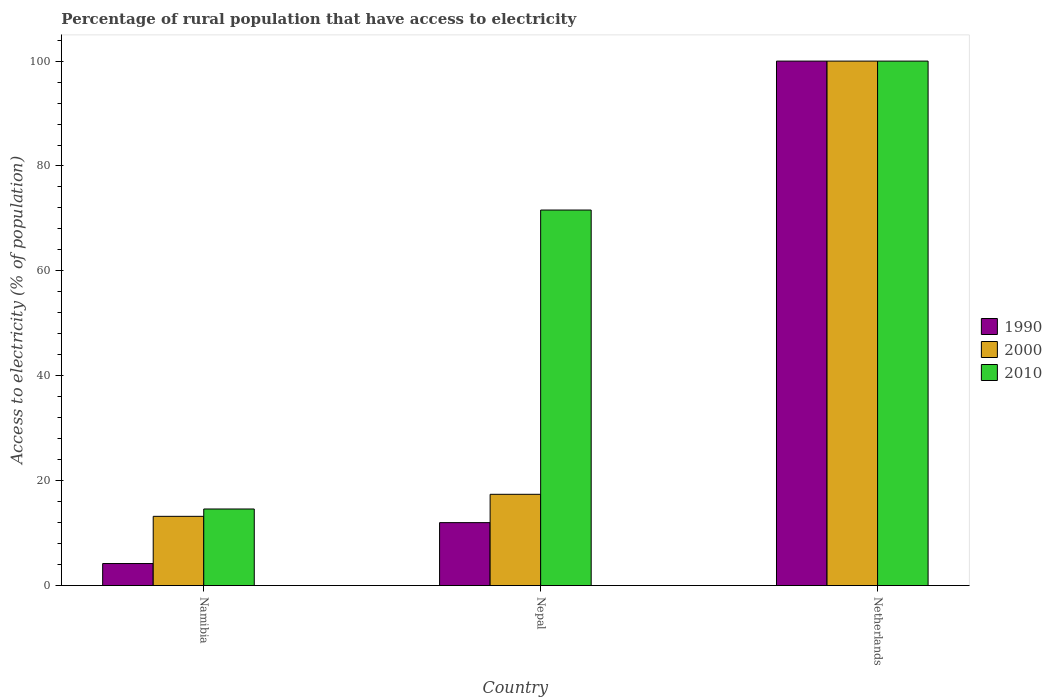Are the number of bars on each tick of the X-axis equal?
Offer a terse response. Yes. How many bars are there on the 2nd tick from the left?
Provide a succinct answer. 3. What is the label of the 2nd group of bars from the left?
Ensure brevity in your answer.  Nepal. Across all countries, what is the maximum percentage of rural population that have access to electricity in 2000?
Give a very brief answer. 100. In which country was the percentage of rural population that have access to electricity in 2010 minimum?
Your answer should be compact. Namibia. What is the total percentage of rural population that have access to electricity in 1990 in the graph?
Make the answer very short. 116.2. What is the difference between the percentage of rural population that have access to electricity in 1990 in Namibia and that in Netherlands?
Your answer should be very brief. -95.8. What is the difference between the percentage of rural population that have access to electricity in 2010 in Netherlands and the percentage of rural population that have access to electricity in 1990 in Namibia?
Give a very brief answer. 95.8. What is the average percentage of rural population that have access to electricity in 2010 per country?
Offer a very short reply. 62.07. What is the difference between the percentage of rural population that have access to electricity of/in 1990 and percentage of rural population that have access to electricity of/in 2000 in Namibia?
Ensure brevity in your answer.  -9. In how many countries, is the percentage of rural population that have access to electricity in 2010 greater than 68 %?
Offer a terse response. 2. What is the ratio of the percentage of rural population that have access to electricity in 1990 in Namibia to that in Nepal?
Offer a very short reply. 0.35. Is the percentage of rural population that have access to electricity in 2010 in Nepal less than that in Netherlands?
Offer a very short reply. Yes. What is the difference between the highest and the second highest percentage of rural population that have access to electricity in 2010?
Provide a short and direct response. 85.4. What is the difference between the highest and the lowest percentage of rural population that have access to electricity in 2010?
Keep it short and to the point. 85.4. In how many countries, is the percentage of rural population that have access to electricity in 2000 greater than the average percentage of rural population that have access to electricity in 2000 taken over all countries?
Provide a succinct answer. 1. Is the sum of the percentage of rural population that have access to electricity in 2010 in Nepal and Netherlands greater than the maximum percentage of rural population that have access to electricity in 2000 across all countries?
Give a very brief answer. Yes. What does the 3rd bar from the left in Nepal represents?
Your answer should be very brief. 2010. What does the 3rd bar from the right in Netherlands represents?
Offer a terse response. 1990. How many bars are there?
Your answer should be compact. 9. Are all the bars in the graph horizontal?
Give a very brief answer. No. What is the difference between two consecutive major ticks on the Y-axis?
Your answer should be compact. 20. Are the values on the major ticks of Y-axis written in scientific E-notation?
Make the answer very short. No. Where does the legend appear in the graph?
Make the answer very short. Center right. How many legend labels are there?
Offer a very short reply. 3. What is the title of the graph?
Your answer should be compact. Percentage of rural population that have access to electricity. Does "2008" appear as one of the legend labels in the graph?
Your answer should be compact. No. What is the label or title of the X-axis?
Your answer should be very brief. Country. What is the label or title of the Y-axis?
Make the answer very short. Access to electricity (% of population). What is the Access to electricity (% of population) of 1990 in Namibia?
Give a very brief answer. 4.2. What is the Access to electricity (% of population) in 2000 in Namibia?
Your response must be concise. 13.2. What is the Access to electricity (% of population) in 1990 in Nepal?
Make the answer very short. 12. What is the Access to electricity (% of population) in 2010 in Nepal?
Provide a short and direct response. 71.6. What is the Access to electricity (% of population) in 1990 in Netherlands?
Offer a very short reply. 100. What is the Access to electricity (% of population) in 2000 in Netherlands?
Your response must be concise. 100. Across all countries, what is the maximum Access to electricity (% of population) in 1990?
Give a very brief answer. 100. Across all countries, what is the maximum Access to electricity (% of population) of 2000?
Give a very brief answer. 100. What is the total Access to electricity (% of population) in 1990 in the graph?
Keep it short and to the point. 116.2. What is the total Access to electricity (% of population) in 2000 in the graph?
Your answer should be very brief. 130.6. What is the total Access to electricity (% of population) of 2010 in the graph?
Ensure brevity in your answer.  186.2. What is the difference between the Access to electricity (% of population) in 2010 in Namibia and that in Nepal?
Provide a short and direct response. -57. What is the difference between the Access to electricity (% of population) in 1990 in Namibia and that in Netherlands?
Your answer should be compact. -95.8. What is the difference between the Access to electricity (% of population) in 2000 in Namibia and that in Netherlands?
Offer a terse response. -86.8. What is the difference between the Access to electricity (% of population) in 2010 in Namibia and that in Netherlands?
Make the answer very short. -85.4. What is the difference between the Access to electricity (% of population) of 1990 in Nepal and that in Netherlands?
Give a very brief answer. -88. What is the difference between the Access to electricity (% of population) of 2000 in Nepal and that in Netherlands?
Give a very brief answer. -82.6. What is the difference between the Access to electricity (% of population) in 2010 in Nepal and that in Netherlands?
Your answer should be compact. -28.4. What is the difference between the Access to electricity (% of population) of 1990 in Namibia and the Access to electricity (% of population) of 2010 in Nepal?
Offer a terse response. -67.4. What is the difference between the Access to electricity (% of population) of 2000 in Namibia and the Access to electricity (% of population) of 2010 in Nepal?
Offer a terse response. -58.4. What is the difference between the Access to electricity (% of population) of 1990 in Namibia and the Access to electricity (% of population) of 2000 in Netherlands?
Provide a succinct answer. -95.8. What is the difference between the Access to electricity (% of population) of 1990 in Namibia and the Access to electricity (% of population) of 2010 in Netherlands?
Give a very brief answer. -95.8. What is the difference between the Access to electricity (% of population) in 2000 in Namibia and the Access to electricity (% of population) in 2010 in Netherlands?
Offer a very short reply. -86.8. What is the difference between the Access to electricity (% of population) in 1990 in Nepal and the Access to electricity (% of population) in 2000 in Netherlands?
Provide a succinct answer. -88. What is the difference between the Access to electricity (% of population) in 1990 in Nepal and the Access to electricity (% of population) in 2010 in Netherlands?
Provide a succinct answer. -88. What is the difference between the Access to electricity (% of population) in 2000 in Nepal and the Access to electricity (% of population) in 2010 in Netherlands?
Provide a succinct answer. -82.6. What is the average Access to electricity (% of population) of 1990 per country?
Offer a very short reply. 38.73. What is the average Access to electricity (% of population) in 2000 per country?
Provide a succinct answer. 43.53. What is the average Access to electricity (% of population) in 2010 per country?
Keep it short and to the point. 62.07. What is the difference between the Access to electricity (% of population) in 1990 and Access to electricity (% of population) in 2000 in Namibia?
Provide a succinct answer. -9. What is the difference between the Access to electricity (% of population) of 1990 and Access to electricity (% of population) of 2010 in Namibia?
Provide a succinct answer. -10.4. What is the difference between the Access to electricity (% of population) of 1990 and Access to electricity (% of population) of 2000 in Nepal?
Offer a very short reply. -5.4. What is the difference between the Access to electricity (% of population) in 1990 and Access to electricity (% of population) in 2010 in Nepal?
Offer a very short reply. -59.6. What is the difference between the Access to electricity (% of population) of 2000 and Access to electricity (% of population) of 2010 in Nepal?
Make the answer very short. -54.2. What is the difference between the Access to electricity (% of population) in 2000 and Access to electricity (% of population) in 2010 in Netherlands?
Provide a short and direct response. 0. What is the ratio of the Access to electricity (% of population) of 2000 in Namibia to that in Nepal?
Your response must be concise. 0.76. What is the ratio of the Access to electricity (% of population) of 2010 in Namibia to that in Nepal?
Provide a short and direct response. 0.2. What is the ratio of the Access to electricity (% of population) of 1990 in Namibia to that in Netherlands?
Your answer should be compact. 0.04. What is the ratio of the Access to electricity (% of population) of 2000 in Namibia to that in Netherlands?
Offer a very short reply. 0.13. What is the ratio of the Access to electricity (% of population) of 2010 in Namibia to that in Netherlands?
Keep it short and to the point. 0.15. What is the ratio of the Access to electricity (% of population) of 1990 in Nepal to that in Netherlands?
Your answer should be compact. 0.12. What is the ratio of the Access to electricity (% of population) of 2000 in Nepal to that in Netherlands?
Provide a succinct answer. 0.17. What is the ratio of the Access to electricity (% of population) of 2010 in Nepal to that in Netherlands?
Provide a succinct answer. 0.72. What is the difference between the highest and the second highest Access to electricity (% of population) in 1990?
Your response must be concise. 88. What is the difference between the highest and the second highest Access to electricity (% of population) of 2000?
Your answer should be compact. 82.6. What is the difference between the highest and the second highest Access to electricity (% of population) of 2010?
Your response must be concise. 28.4. What is the difference between the highest and the lowest Access to electricity (% of population) in 1990?
Make the answer very short. 95.8. What is the difference between the highest and the lowest Access to electricity (% of population) in 2000?
Your answer should be very brief. 86.8. What is the difference between the highest and the lowest Access to electricity (% of population) in 2010?
Ensure brevity in your answer.  85.4. 